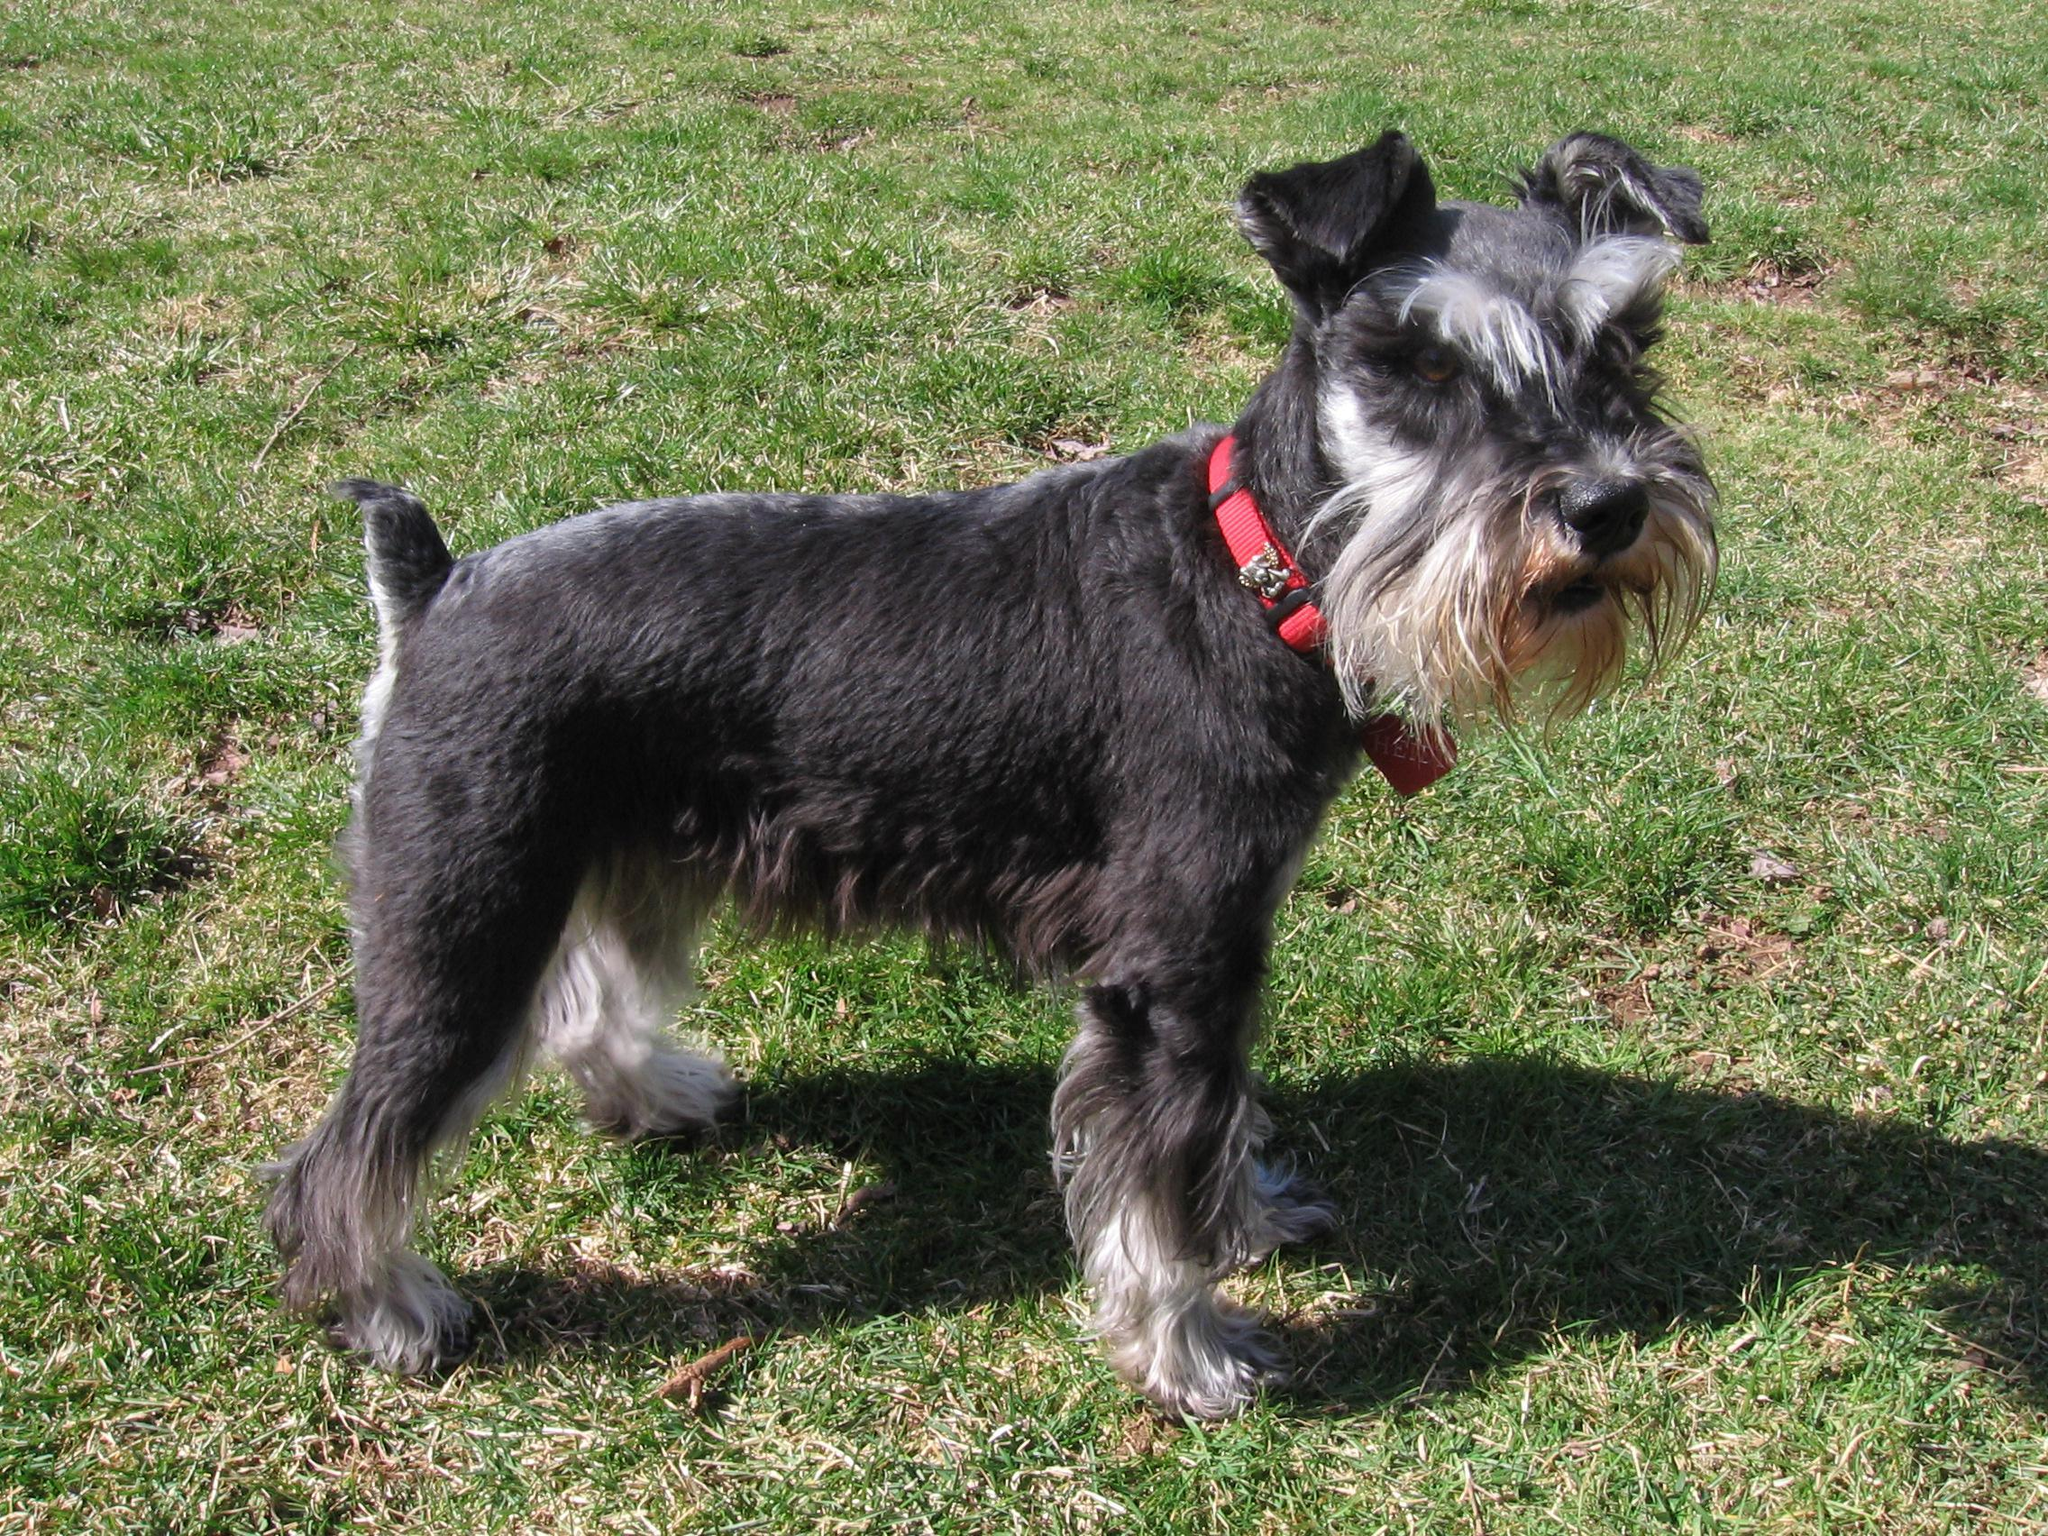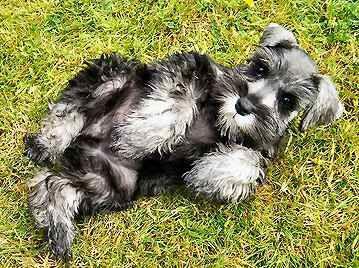The first image is the image on the left, the second image is the image on the right. For the images shown, is this caption "One schnauzer puppy is sitting on its bottom." true? Answer yes or no. No. 